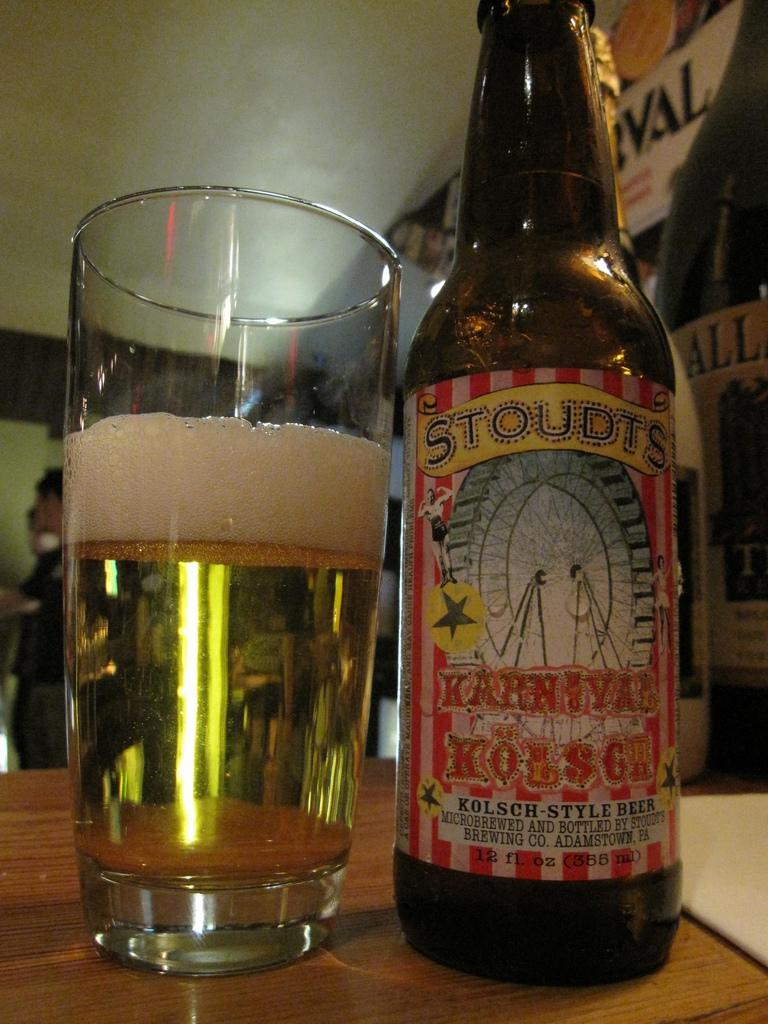Provide a one-sentence caption for the provided image. A Glass of bear with a bottle on the side shows Stoudts Karnival brand. 